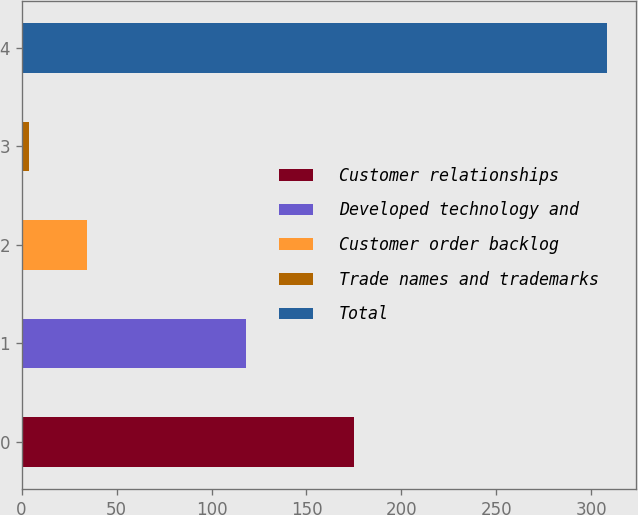<chart> <loc_0><loc_0><loc_500><loc_500><bar_chart><fcel>Customer relationships<fcel>Developed technology and<fcel>Customer order backlog<fcel>Trade names and trademarks<fcel>Total<nl><fcel>175<fcel>118<fcel>34.4<fcel>4<fcel>308<nl></chart> 